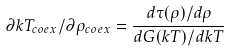<formula> <loc_0><loc_0><loc_500><loc_500>\partial k T _ { c o e x } / \partial \rho _ { c o e x } = \frac { d \tau ( \rho ) / d \rho } { d G ( k T ) / d k T }</formula> 